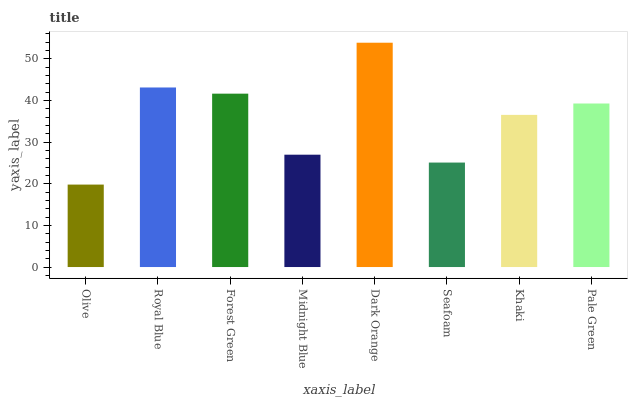Is Olive the minimum?
Answer yes or no. Yes. Is Dark Orange the maximum?
Answer yes or no. Yes. Is Royal Blue the minimum?
Answer yes or no. No. Is Royal Blue the maximum?
Answer yes or no. No. Is Royal Blue greater than Olive?
Answer yes or no. Yes. Is Olive less than Royal Blue?
Answer yes or no. Yes. Is Olive greater than Royal Blue?
Answer yes or no. No. Is Royal Blue less than Olive?
Answer yes or no. No. Is Pale Green the high median?
Answer yes or no. Yes. Is Khaki the low median?
Answer yes or no. Yes. Is Khaki the high median?
Answer yes or no. No. Is Royal Blue the low median?
Answer yes or no. No. 